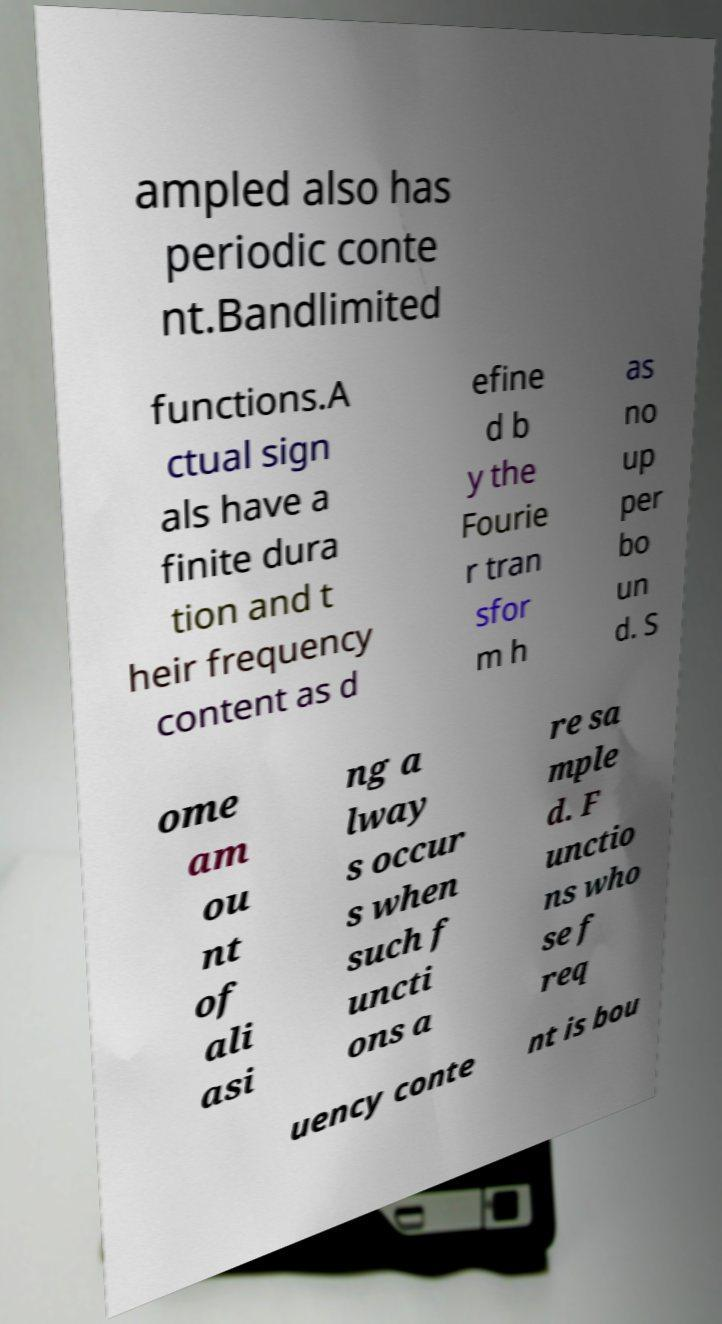Please identify and transcribe the text found in this image. ampled also has periodic conte nt.Bandlimited functions.A ctual sign als have a finite dura tion and t heir frequency content as d efine d b y the Fourie r tran sfor m h as no up per bo un d. S ome am ou nt of ali asi ng a lway s occur s when such f uncti ons a re sa mple d. F unctio ns who se f req uency conte nt is bou 